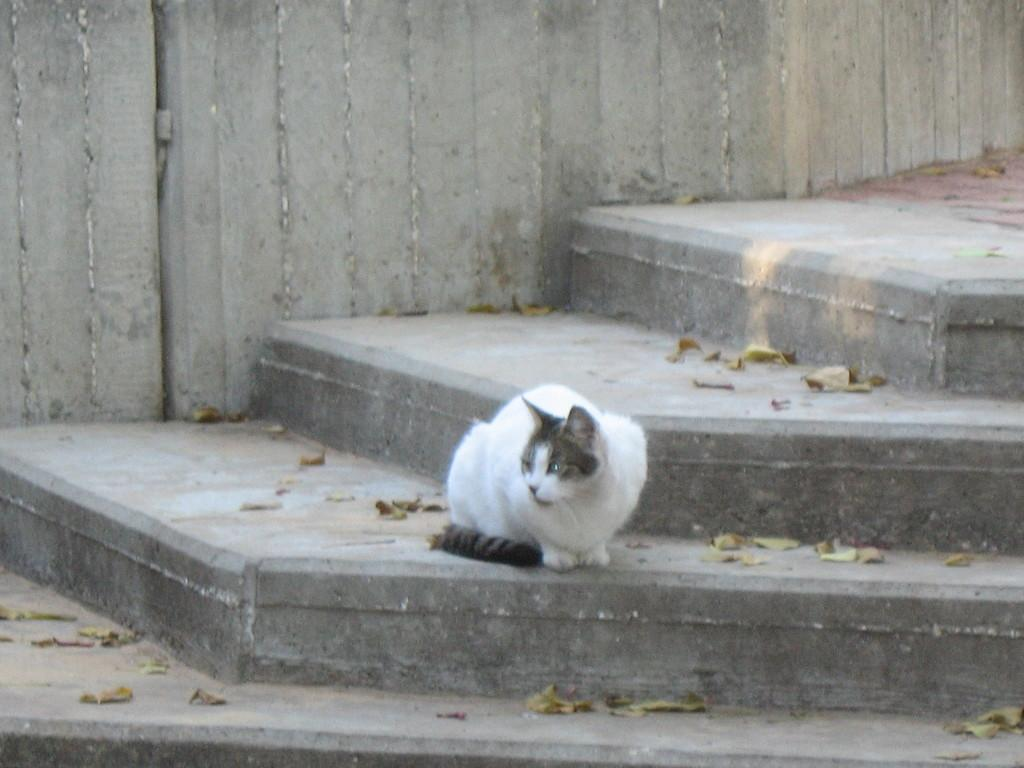What type of animal is in the image? There is a white cat in the image. Where is the cat located in the image? The cat is on the stairs. What can be seen on the ground in the image? There are dry leaves visible in the image. What is visible in the background of the image? There is a wall in the background of the image. What type of spoon is being used by the cat in the image? There is no spoon present in the image; it features a white cat on the stairs with dry leaves on the ground and a wall in the background. 